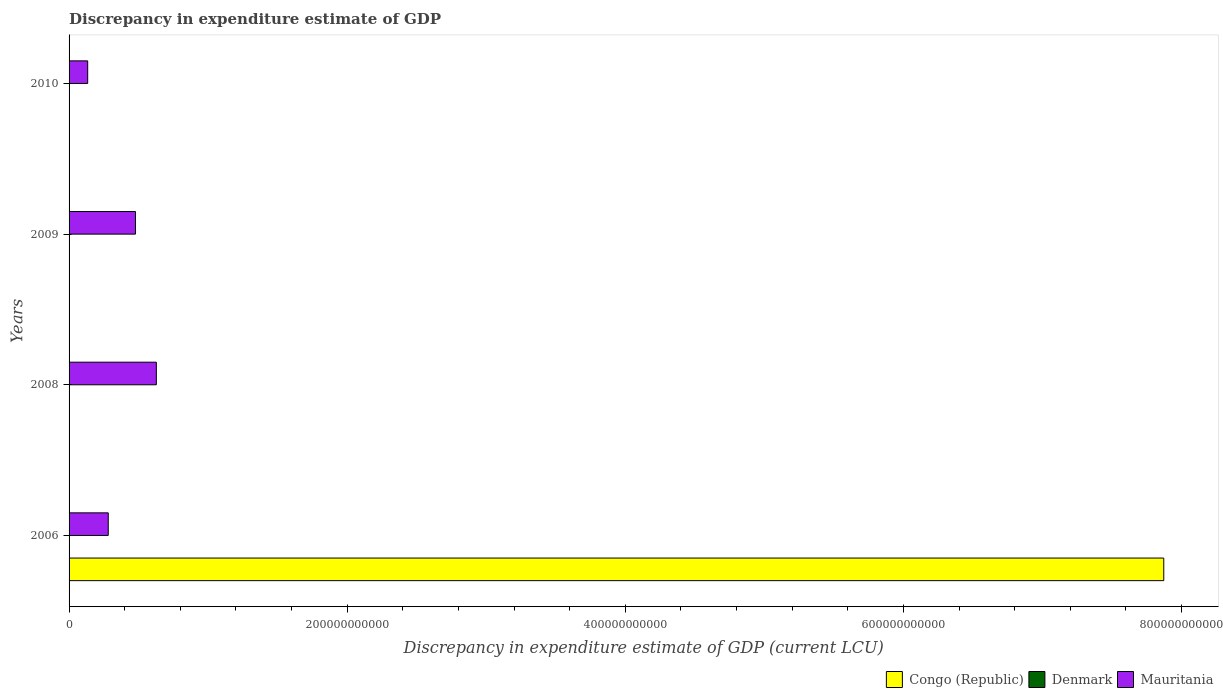How many groups of bars are there?
Ensure brevity in your answer.  4. Are the number of bars per tick equal to the number of legend labels?
Provide a succinct answer. No. How many bars are there on the 3rd tick from the top?
Keep it short and to the point. 2. How many bars are there on the 3rd tick from the bottom?
Your answer should be very brief. 2. What is the label of the 1st group of bars from the top?
Keep it short and to the point. 2010. Across all years, what is the maximum discrepancy in expenditure estimate of GDP in Denmark?
Your answer should be compact. 1.00e+06. Across all years, what is the minimum discrepancy in expenditure estimate of GDP in Congo (Republic)?
Offer a very short reply. 0. What is the total discrepancy in expenditure estimate of GDP in Congo (Republic) in the graph?
Your response must be concise. 7.87e+11. What is the difference between the discrepancy in expenditure estimate of GDP in Mauritania in 2008 and that in 2009?
Give a very brief answer. 1.50e+1. What is the average discrepancy in expenditure estimate of GDP in Denmark per year?
Ensure brevity in your answer.  5.00e+05. In the year 2010, what is the difference between the discrepancy in expenditure estimate of GDP in Denmark and discrepancy in expenditure estimate of GDP in Mauritania?
Offer a terse response. -1.34e+1. In how many years, is the discrepancy in expenditure estimate of GDP in Congo (Republic) greater than 80000000000 LCU?
Keep it short and to the point. 1. What is the ratio of the discrepancy in expenditure estimate of GDP in Congo (Republic) in 2006 to that in 2010?
Offer a very short reply. 7.87e+09. What is the difference between the highest and the second highest discrepancy in expenditure estimate of GDP in Mauritania?
Your answer should be compact. 1.50e+1. Is the sum of the discrepancy in expenditure estimate of GDP in Congo (Republic) in 2006 and 2009 greater than the maximum discrepancy in expenditure estimate of GDP in Denmark across all years?
Provide a short and direct response. Yes. Are all the bars in the graph horizontal?
Provide a short and direct response. Yes. How many years are there in the graph?
Your answer should be compact. 4. What is the difference between two consecutive major ticks on the X-axis?
Make the answer very short. 2.00e+11. Does the graph contain grids?
Provide a succinct answer. No. Where does the legend appear in the graph?
Your answer should be compact. Bottom right. How many legend labels are there?
Give a very brief answer. 3. How are the legend labels stacked?
Keep it short and to the point. Horizontal. What is the title of the graph?
Make the answer very short. Discrepancy in expenditure estimate of GDP. Does "Latvia" appear as one of the legend labels in the graph?
Ensure brevity in your answer.  No. What is the label or title of the X-axis?
Provide a short and direct response. Discrepancy in expenditure estimate of GDP (current LCU). What is the label or title of the Y-axis?
Provide a succinct answer. Years. What is the Discrepancy in expenditure estimate of GDP (current LCU) of Congo (Republic) in 2006?
Provide a succinct answer. 7.87e+11. What is the Discrepancy in expenditure estimate of GDP (current LCU) of Mauritania in 2006?
Make the answer very short. 2.82e+1. What is the Discrepancy in expenditure estimate of GDP (current LCU) of Congo (Republic) in 2008?
Provide a succinct answer. 0. What is the Discrepancy in expenditure estimate of GDP (current LCU) of Mauritania in 2008?
Provide a succinct answer. 6.28e+1. What is the Discrepancy in expenditure estimate of GDP (current LCU) in Congo (Republic) in 2009?
Keep it short and to the point. 0. What is the Discrepancy in expenditure estimate of GDP (current LCU) in Mauritania in 2009?
Provide a short and direct response. 4.77e+1. What is the Discrepancy in expenditure estimate of GDP (current LCU) of Congo (Republic) in 2010?
Offer a very short reply. 100. What is the Discrepancy in expenditure estimate of GDP (current LCU) in Denmark in 2010?
Provide a short and direct response. 1.00e+06. What is the Discrepancy in expenditure estimate of GDP (current LCU) of Mauritania in 2010?
Your answer should be very brief. 1.34e+1. Across all years, what is the maximum Discrepancy in expenditure estimate of GDP (current LCU) of Congo (Republic)?
Offer a very short reply. 7.87e+11. Across all years, what is the maximum Discrepancy in expenditure estimate of GDP (current LCU) in Mauritania?
Give a very brief answer. 6.28e+1. Across all years, what is the minimum Discrepancy in expenditure estimate of GDP (current LCU) of Congo (Republic)?
Your answer should be very brief. 0. Across all years, what is the minimum Discrepancy in expenditure estimate of GDP (current LCU) of Denmark?
Provide a short and direct response. 0. Across all years, what is the minimum Discrepancy in expenditure estimate of GDP (current LCU) in Mauritania?
Give a very brief answer. 1.34e+1. What is the total Discrepancy in expenditure estimate of GDP (current LCU) of Congo (Republic) in the graph?
Give a very brief answer. 7.87e+11. What is the total Discrepancy in expenditure estimate of GDP (current LCU) of Mauritania in the graph?
Ensure brevity in your answer.  1.52e+11. What is the difference between the Discrepancy in expenditure estimate of GDP (current LCU) in Mauritania in 2006 and that in 2008?
Your answer should be compact. -3.46e+1. What is the difference between the Discrepancy in expenditure estimate of GDP (current LCU) of Congo (Republic) in 2006 and that in 2009?
Your answer should be compact. 7.87e+11. What is the difference between the Discrepancy in expenditure estimate of GDP (current LCU) of Mauritania in 2006 and that in 2009?
Your response must be concise. -1.96e+1. What is the difference between the Discrepancy in expenditure estimate of GDP (current LCU) in Congo (Republic) in 2006 and that in 2010?
Give a very brief answer. 7.87e+11. What is the difference between the Discrepancy in expenditure estimate of GDP (current LCU) in Mauritania in 2006 and that in 2010?
Give a very brief answer. 1.48e+1. What is the difference between the Discrepancy in expenditure estimate of GDP (current LCU) of Mauritania in 2008 and that in 2009?
Ensure brevity in your answer.  1.50e+1. What is the difference between the Discrepancy in expenditure estimate of GDP (current LCU) in Denmark in 2008 and that in 2010?
Your answer should be very brief. 0. What is the difference between the Discrepancy in expenditure estimate of GDP (current LCU) in Mauritania in 2008 and that in 2010?
Provide a short and direct response. 4.94e+1. What is the difference between the Discrepancy in expenditure estimate of GDP (current LCU) in Congo (Republic) in 2009 and that in 2010?
Your response must be concise. -100. What is the difference between the Discrepancy in expenditure estimate of GDP (current LCU) of Mauritania in 2009 and that in 2010?
Offer a terse response. 3.44e+1. What is the difference between the Discrepancy in expenditure estimate of GDP (current LCU) of Congo (Republic) in 2006 and the Discrepancy in expenditure estimate of GDP (current LCU) of Denmark in 2008?
Make the answer very short. 7.87e+11. What is the difference between the Discrepancy in expenditure estimate of GDP (current LCU) in Congo (Republic) in 2006 and the Discrepancy in expenditure estimate of GDP (current LCU) in Mauritania in 2008?
Ensure brevity in your answer.  7.24e+11. What is the difference between the Discrepancy in expenditure estimate of GDP (current LCU) of Congo (Republic) in 2006 and the Discrepancy in expenditure estimate of GDP (current LCU) of Mauritania in 2009?
Your response must be concise. 7.39e+11. What is the difference between the Discrepancy in expenditure estimate of GDP (current LCU) of Congo (Republic) in 2006 and the Discrepancy in expenditure estimate of GDP (current LCU) of Denmark in 2010?
Give a very brief answer. 7.87e+11. What is the difference between the Discrepancy in expenditure estimate of GDP (current LCU) of Congo (Republic) in 2006 and the Discrepancy in expenditure estimate of GDP (current LCU) of Mauritania in 2010?
Keep it short and to the point. 7.74e+11. What is the difference between the Discrepancy in expenditure estimate of GDP (current LCU) in Denmark in 2008 and the Discrepancy in expenditure estimate of GDP (current LCU) in Mauritania in 2009?
Ensure brevity in your answer.  -4.77e+1. What is the difference between the Discrepancy in expenditure estimate of GDP (current LCU) in Denmark in 2008 and the Discrepancy in expenditure estimate of GDP (current LCU) in Mauritania in 2010?
Offer a terse response. -1.34e+1. What is the difference between the Discrepancy in expenditure estimate of GDP (current LCU) of Congo (Republic) in 2009 and the Discrepancy in expenditure estimate of GDP (current LCU) of Denmark in 2010?
Your answer should be very brief. -1.00e+06. What is the difference between the Discrepancy in expenditure estimate of GDP (current LCU) of Congo (Republic) in 2009 and the Discrepancy in expenditure estimate of GDP (current LCU) of Mauritania in 2010?
Your answer should be compact. -1.34e+1. What is the average Discrepancy in expenditure estimate of GDP (current LCU) in Congo (Republic) per year?
Ensure brevity in your answer.  1.97e+11. What is the average Discrepancy in expenditure estimate of GDP (current LCU) in Denmark per year?
Offer a very short reply. 5.00e+05. What is the average Discrepancy in expenditure estimate of GDP (current LCU) in Mauritania per year?
Keep it short and to the point. 3.80e+1. In the year 2006, what is the difference between the Discrepancy in expenditure estimate of GDP (current LCU) in Congo (Republic) and Discrepancy in expenditure estimate of GDP (current LCU) in Mauritania?
Your response must be concise. 7.59e+11. In the year 2008, what is the difference between the Discrepancy in expenditure estimate of GDP (current LCU) of Denmark and Discrepancy in expenditure estimate of GDP (current LCU) of Mauritania?
Make the answer very short. -6.28e+1. In the year 2009, what is the difference between the Discrepancy in expenditure estimate of GDP (current LCU) of Congo (Republic) and Discrepancy in expenditure estimate of GDP (current LCU) of Mauritania?
Make the answer very short. -4.77e+1. In the year 2010, what is the difference between the Discrepancy in expenditure estimate of GDP (current LCU) in Congo (Republic) and Discrepancy in expenditure estimate of GDP (current LCU) in Denmark?
Offer a very short reply. -1.00e+06. In the year 2010, what is the difference between the Discrepancy in expenditure estimate of GDP (current LCU) of Congo (Republic) and Discrepancy in expenditure estimate of GDP (current LCU) of Mauritania?
Offer a terse response. -1.34e+1. In the year 2010, what is the difference between the Discrepancy in expenditure estimate of GDP (current LCU) of Denmark and Discrepancy in expenditure estimate of GDP (current LCU) of Mauritania?
Keep it short and to the point. -1.34e+1. What is the ratio of the Discrepancy in expenditure estimate of GDP (current LCU) in Mauritania in 2006 to that in 2008?
Keep it short and to the point. 0.45. What is the ratio of the Discrepancy in expenditure estimate of GDP (current LCU) in Congo (Republic) in 2006 to that in 2009?
Provide a succinct answer. 1.57e+15. What is the ratio of the Discrepancy in expenditure estimate of GDP (current LCU) in Mauritania in 2006 to that in 2009?
Your answer should be compact. 0.59. What is the ratio of the Discrepancy in expenditure estimate of GDP (current LCU) in Congo (Republic) in 2006 to that in 2010?
Give a very brief answer. 7.87e+09. What is the ratio of the Discrepancy in expenditure estimate of GDP (current LCU) in Mauritania in 2006 to that in 2010?
Offer a terse response. 2.1. What is the ratio of the Discrepancy in expenditure estimate of GDP (current LCU) of Mauritania in 2008 to that in 2009?
Make the answer very short. 1.31. What is the ratio of the Discrepancy in expenditure estimate of GDP (current LCU) of Mauritania in 2008 to that in 2010?
Your response must be concise. 4.69. What is the ratio of the Discrepancy in expenditure estimate of GDP (current LCU) of Congo (Republic) in 2009 to that in 2010?
Keep it short and to the point. 0. What is the ratio of the Discrepancy in expenditure estimate of GDP (current LCU) of Mauritania in 2009 to that in 2010?
Provide a succinct answer. 3.57. What is the difference between the highest and the second highest Discrepancy in expenditure estimate of GDP (current LCU) in Congo (Republic)?
Make the answer very short. 7.87e+11. What is the difference between the highest and the second highest Discrepancy in expenditure estimate of GDP (current LCU) in Mauritania?
Your response must be concise. 1.50e+1. What is the difference between the highest and the lowest Discrepancy in expenditure estimate of GDP (current LCU) in Congo (Republic)?
Give a very brief answer. 7.87e+11. What is the difference between the highest and the lowest Discrepancy in expenditure estimate of GDP (current LCU) in Denmark?
Offer a very short reply. 1.00e+06. What is the difference between the highest and the lowest Discrepancy in expenditure estimate of GDP (current LCU) of Mauritania?
Your response must be concise. 4.94e+1. 